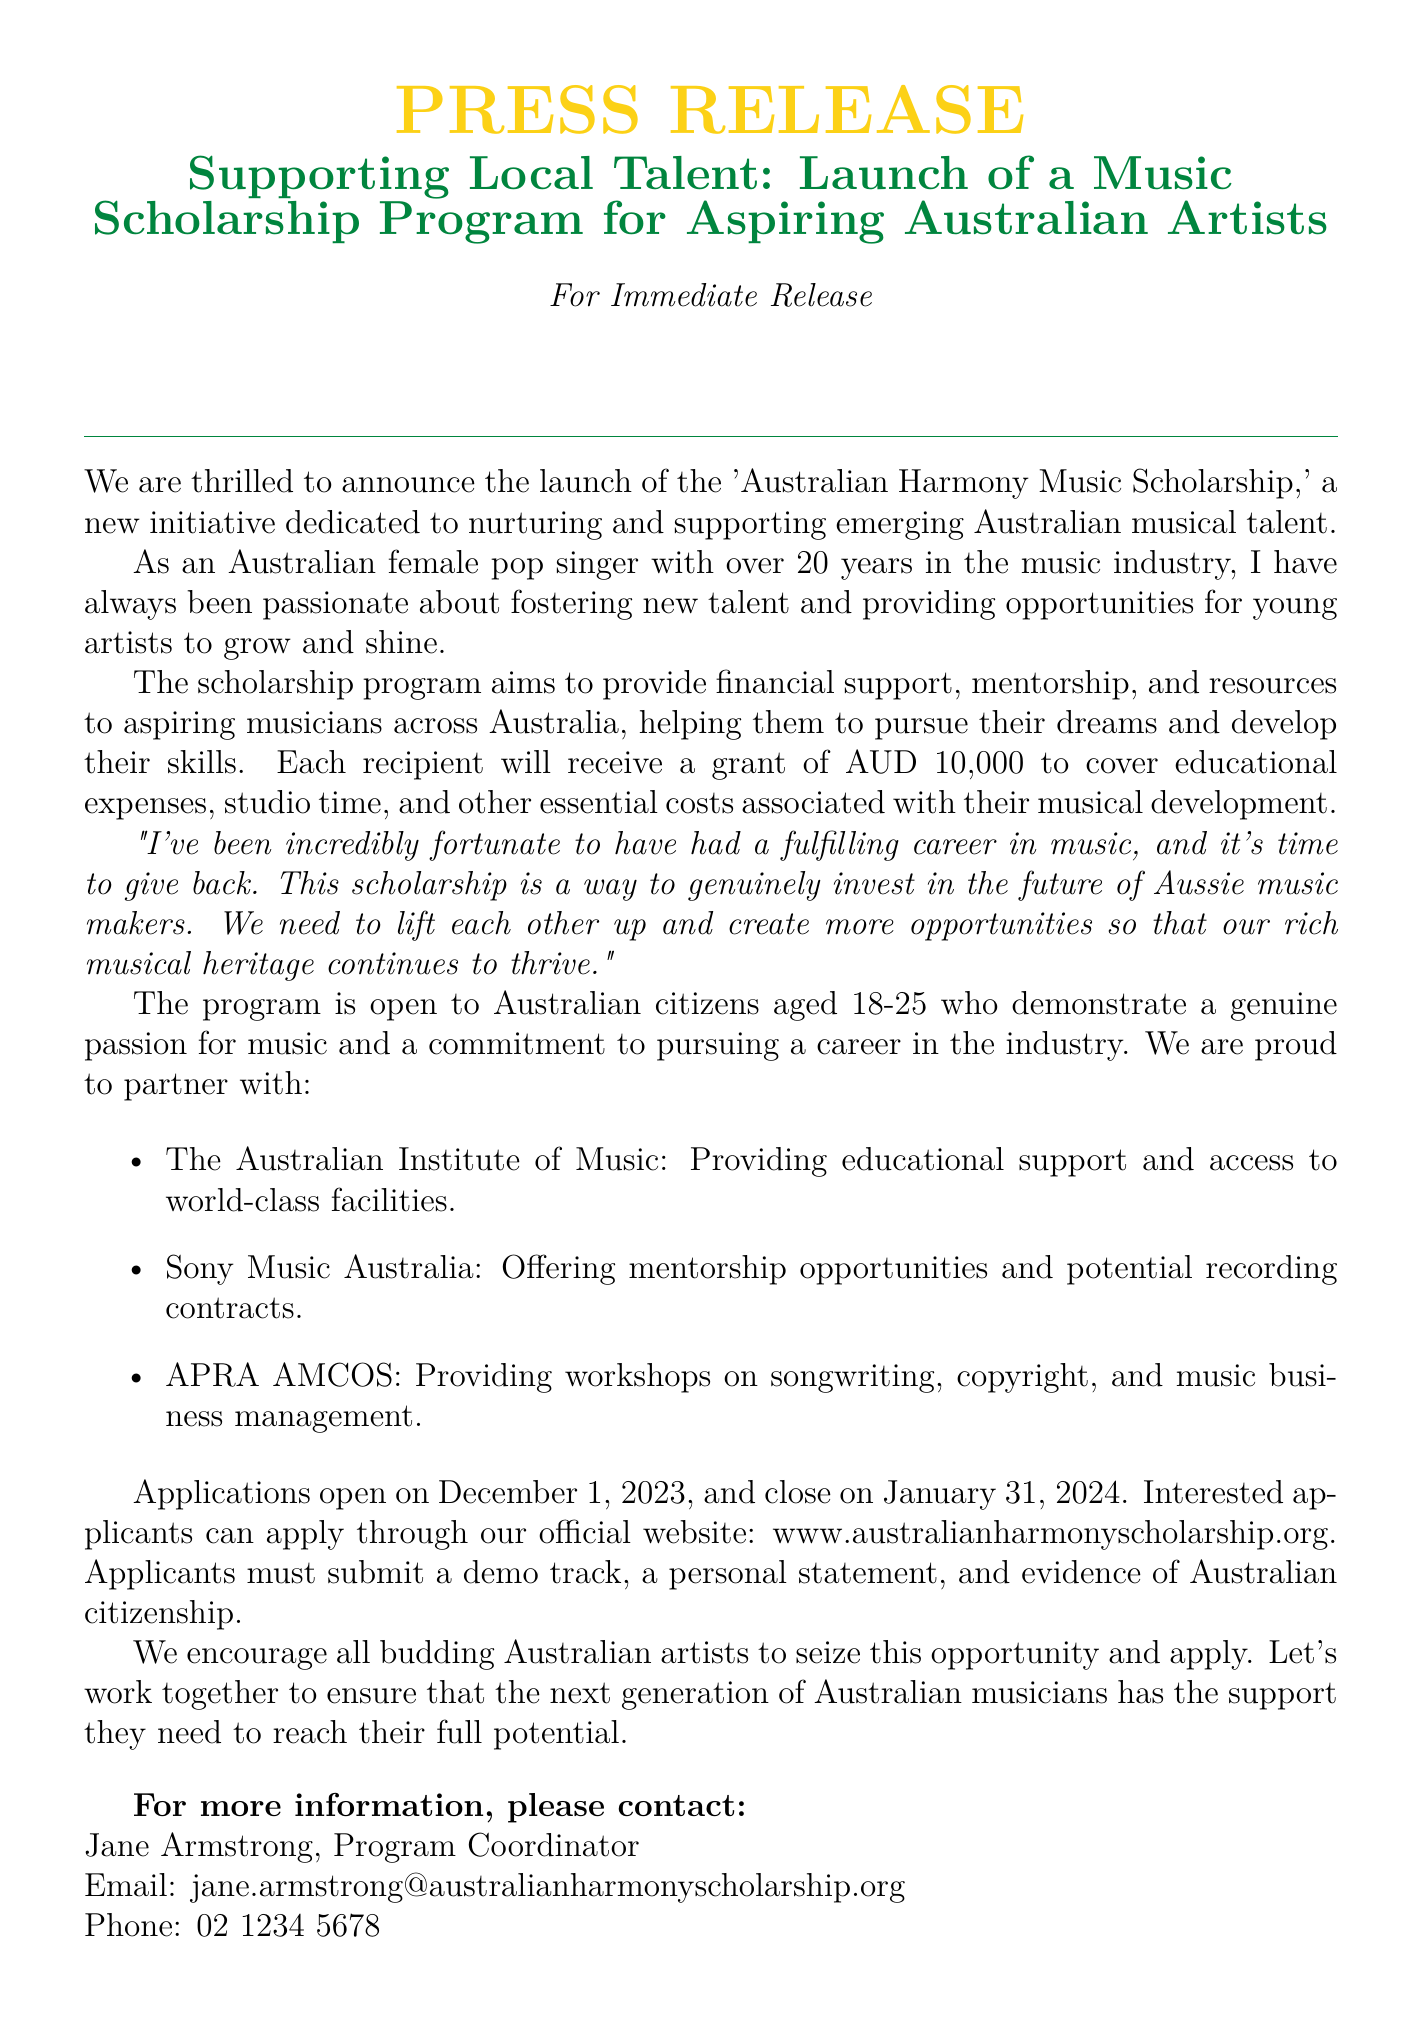What is the name of the scholarship program? The document states the scholarship is called the 'Australian Harmony Music Scholarship.'
Answer: Australian Harmony Music Scholarship What is the grant amount for each scholarship recipient? The document specifies that each recipient will receive a grant of AUD 10,000.
Answer: AUD 10,000 Who is the Program Coordinator for the scholarship? The document mentions Jane Armstrong as the Program Coordinator.
Answer: Jane Armstrong When do applications open and close? The document indicates that applications open on December 1, 2023, and close on January 31, 2024.
Answer: December 1, 2023, and January 31, 2024 What age range must applicants fall within? The document states that applicants must be aged 18-25 years old.
Answer: 18-25 Which organization provides educational support for the scholarship? According to the document, the Australian Institute of Music provides educational support.
Answer: The Australian Institute of Music What is required from applicants during the application process? The document outlines that applicants must submit a demo track, a personal statement, and evidence of Australian citizenship.
Answer: A demo track, a personal statement, and evidence of Australian citizenship What is the main purpose of the scholarship program? The document describes the purpose as nurturing and supporting emerging Australian musical talent.
Answer: Nurturing and supporting emerging Australian musical talent 